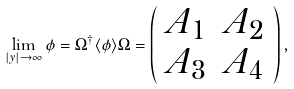Convert formula to latex. <formula><loc_0><loc_0><loc_500><loc_500>\lim _ { | y | \rightarrow \infty } \phi = \Omega ^ { \dagger } \langle \phi \rangle \Omega = \left ( \begin{array} { c c } A _ { 1 } & A _ { 2 } \\ A _ { 3 } & A _ { 4 } \end{array} \right ) ,</formula> 